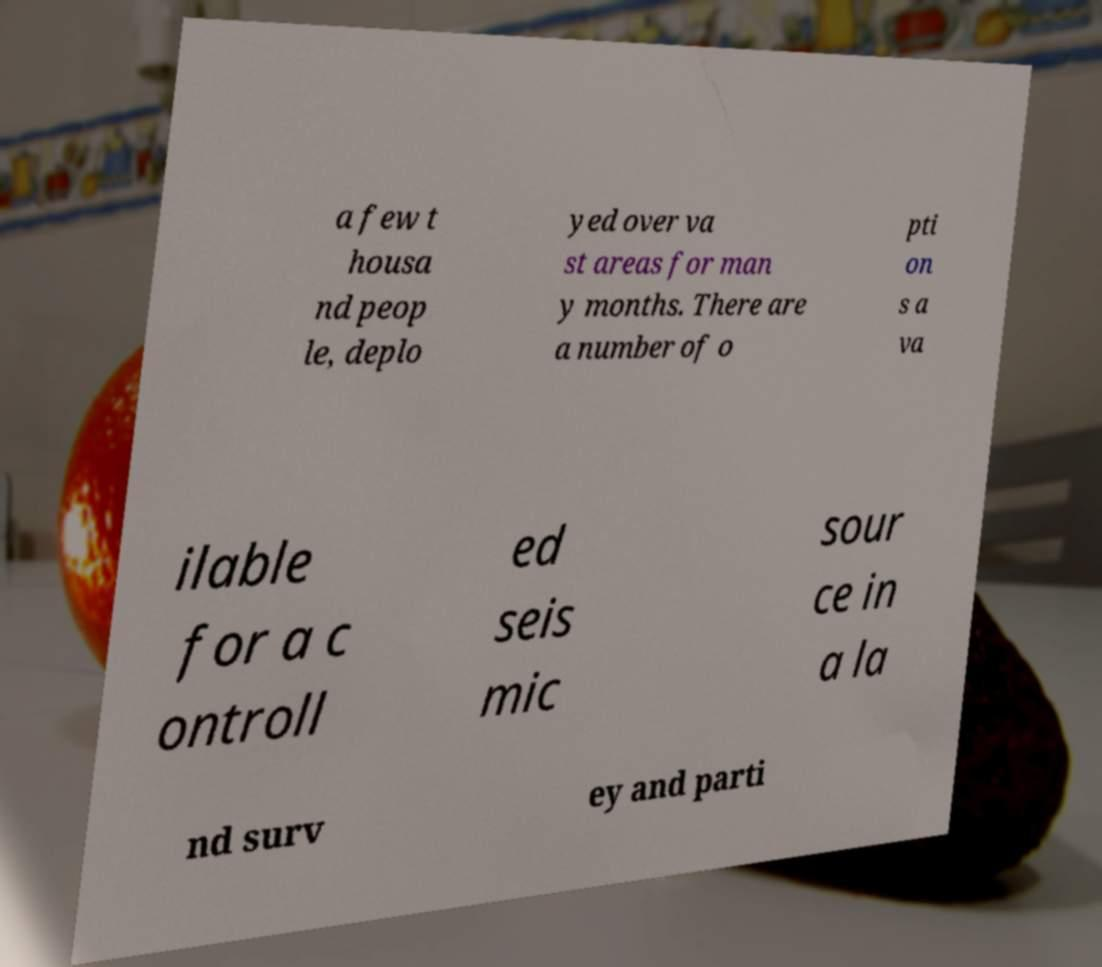There's text embedded in this image that I need extracted. Can you transcribe it verbatim? a few t housa nd peop le, deplo yed over va st areas for man y months. There are a number of o pti on s a va ilable for a c ontroll ed seis mic sour ce in a la nd surv ey and parti 